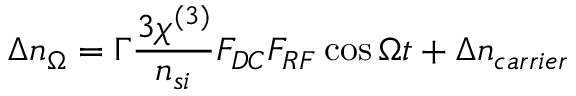<formula> <loc_0><loc_0><loc_500><loc_500>\Delta n _ { \Omega } = \Gamma \frac { 3 \chi ^ { ( 3 ) } } { n _ { s i } } F _ { D C } F _ { R F } \cos \Omega t + \Delta n _ { c a r r i e r }</formula> 